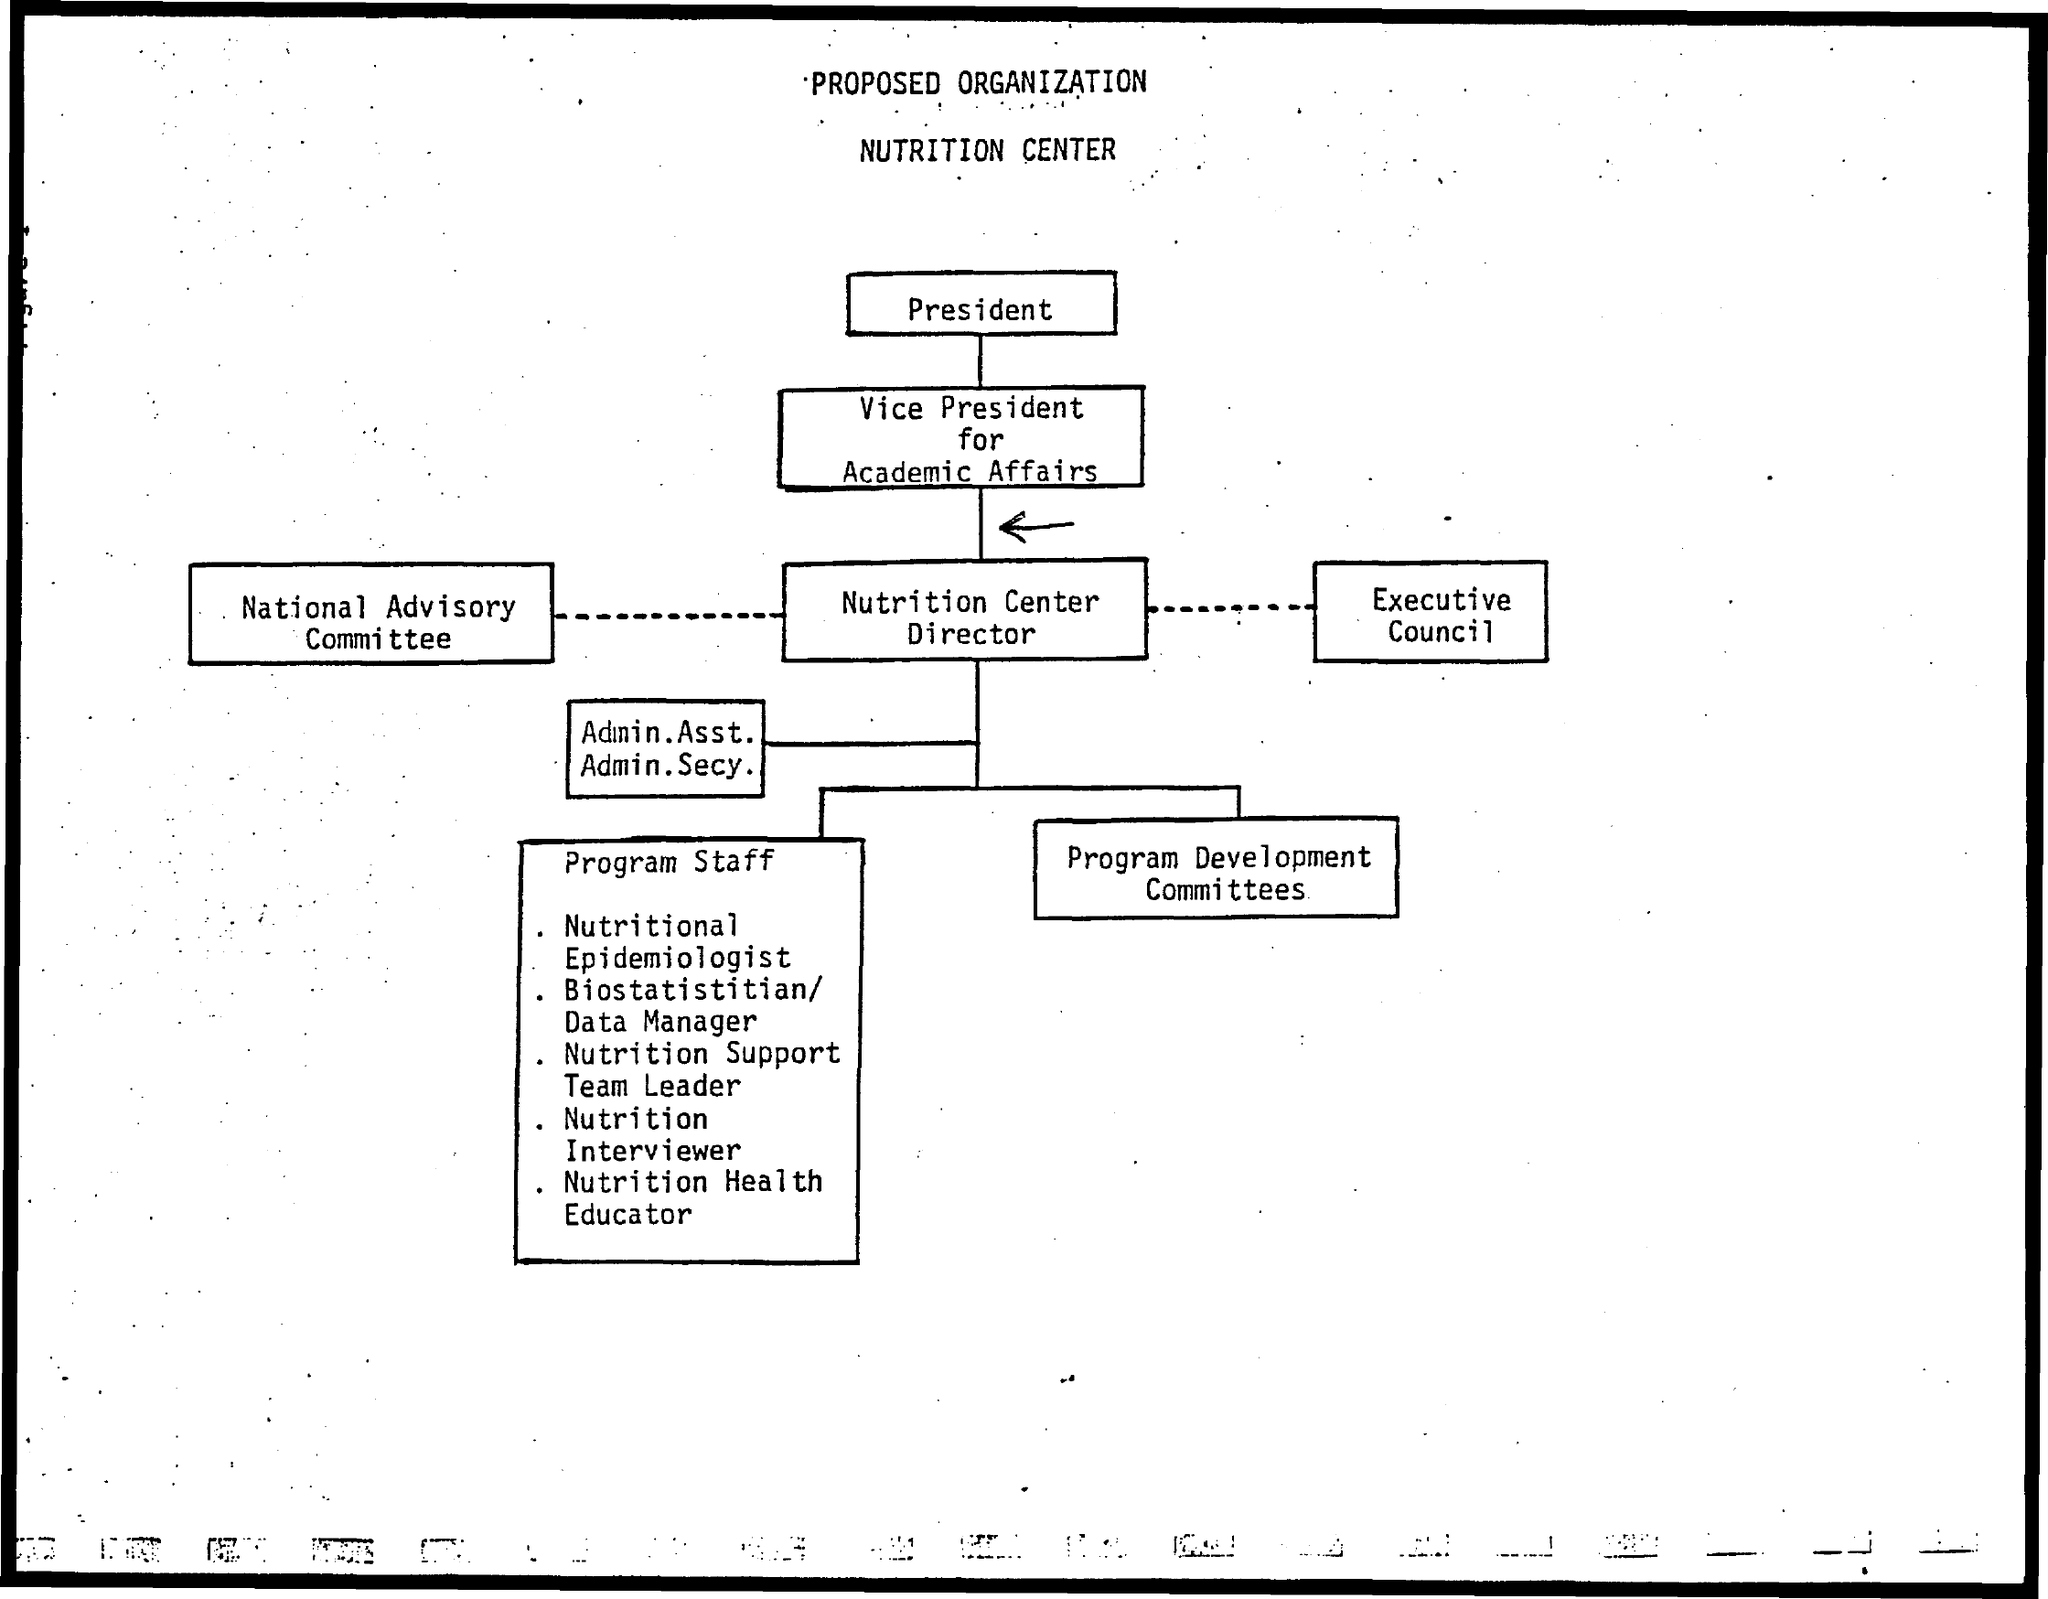The organization structure is for which center?
Keep it short and to the point. Nutrition Center. 